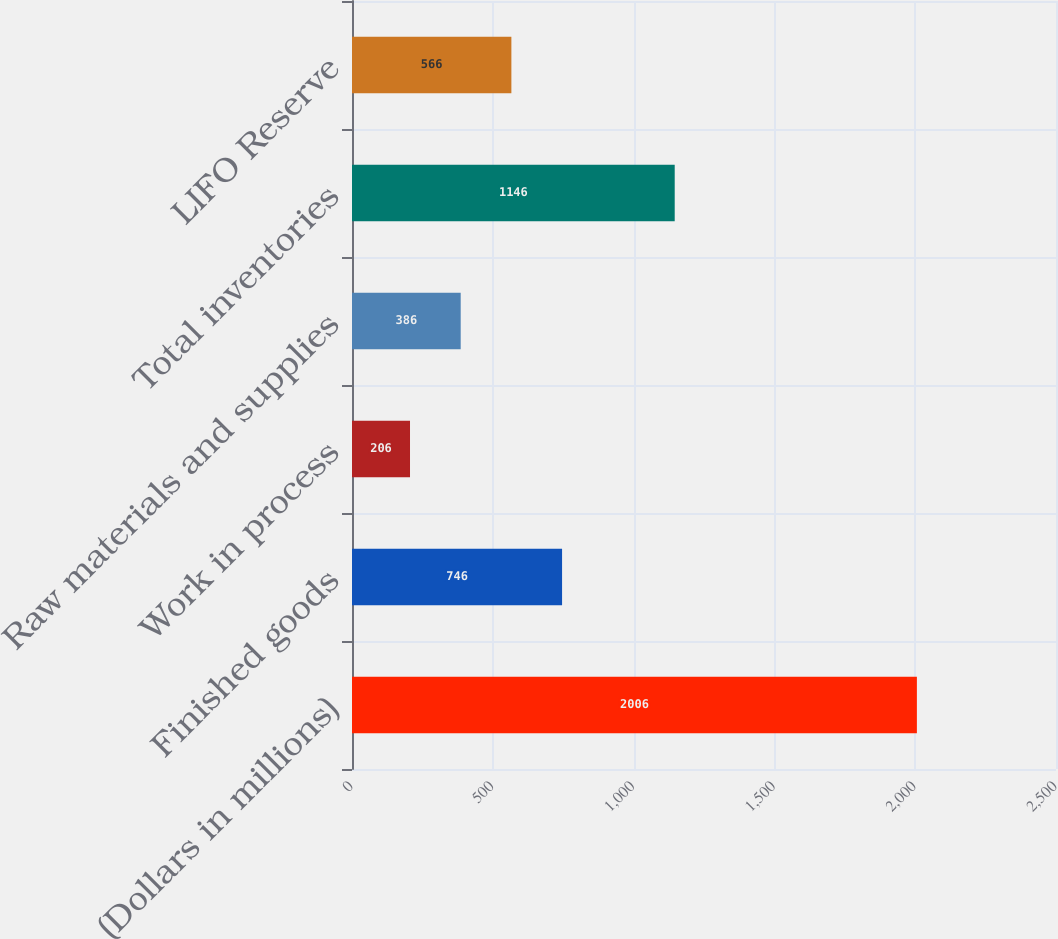<chart> <loc_0><loc_0><loc_500><loc_500><bar_chart><fcel>(Dollars in millions)<fcel>Finished goods<fcel>Work in process<fcel>Raw materials and supplies<fcel>Total inventories<fcel>LIFO Reserve<nl><fcel>2006<fcel>746<fcel>206<fcel>386<fcel>1146<fcel>566<nl></chart> 